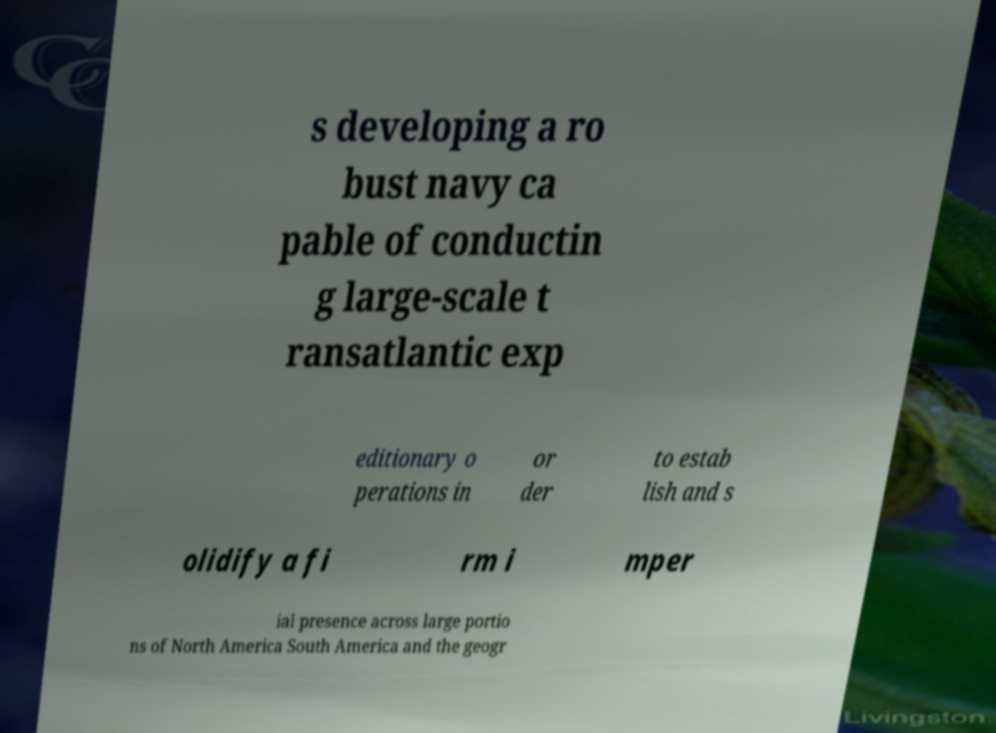For documentation purposes, I need the text within this image transcribed. Could you provide that? s developing a ro bust navy ca pable of conductin g large-scale t ransatlantic exp editionary o perations in or der to estab lish and s olidify a fi rm i mper ial presence across large portio ns of North America South America and the geogr 